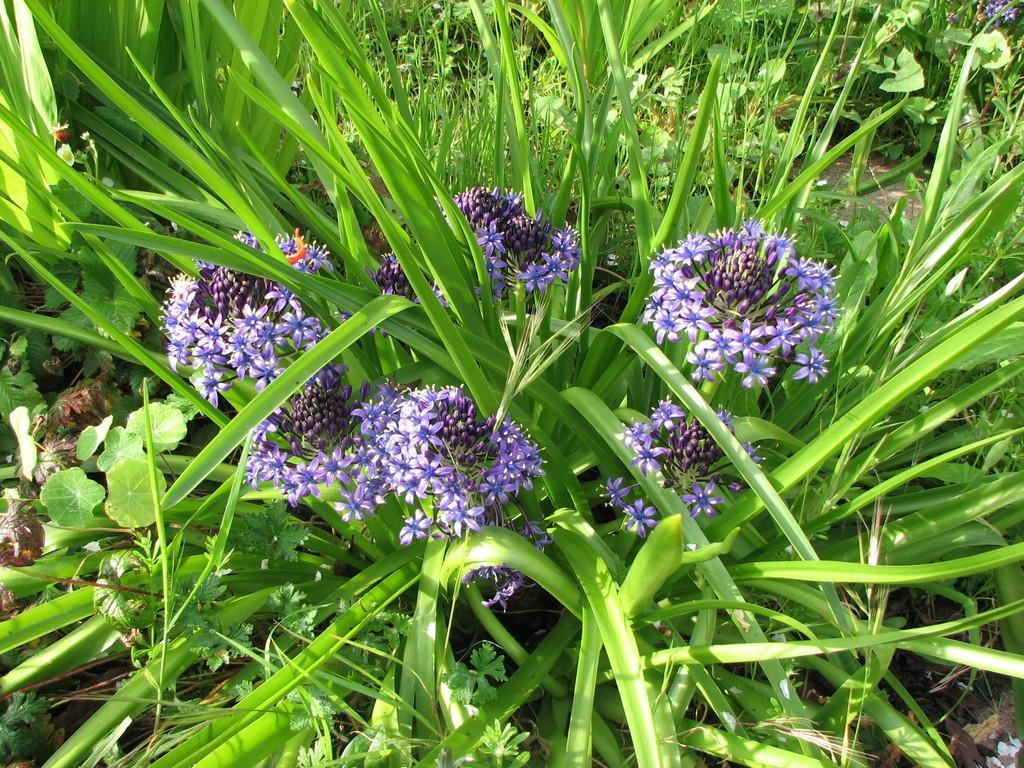Could you give a brief overview of what you see in this image? In this picture we can see plants with purple flowers. 